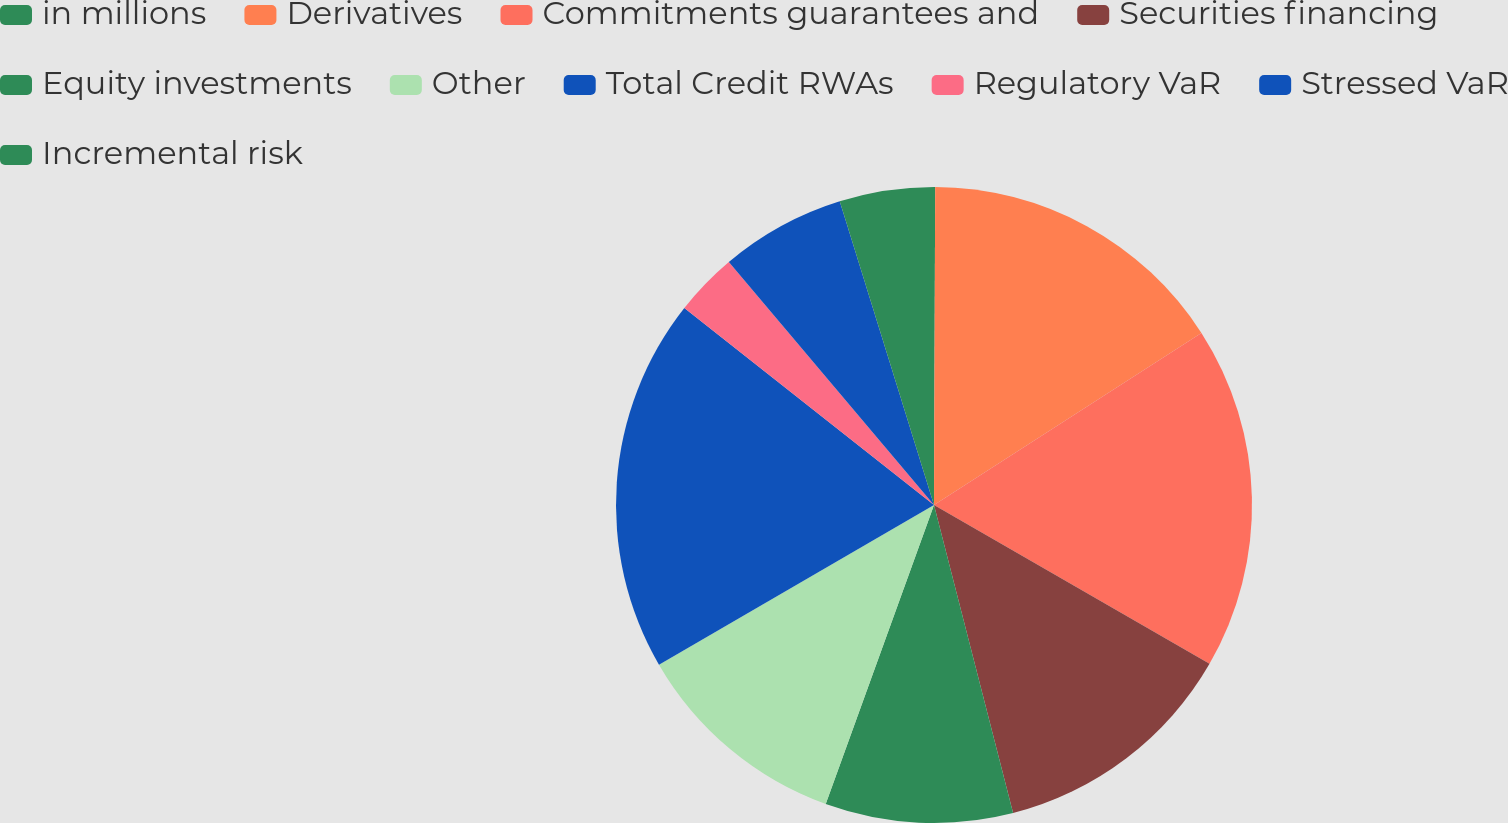Convert chart. <chart><loc_0><loc_0><loc_500><loc_500><pie_chart><fcel>in millions<fcel>Derivatives<fcel>Commitments guarantees and<fcel>Securities financing<fcel>Equity investments<fcel>Other<fcel>Total Credit RWAs<fcel>Regulatory VaR<fcel>Stressed VaR<fcel>Incremental risk<nl><fcel>0.06%<fcel>15.84%<fcel>17.42%<fcel>12.68%<fcel>9.53%<fcel>11.1%<fcel>19.0%<fcel>3.21%<fcel>6.37%<fcel>4.79%<nl></chart> 